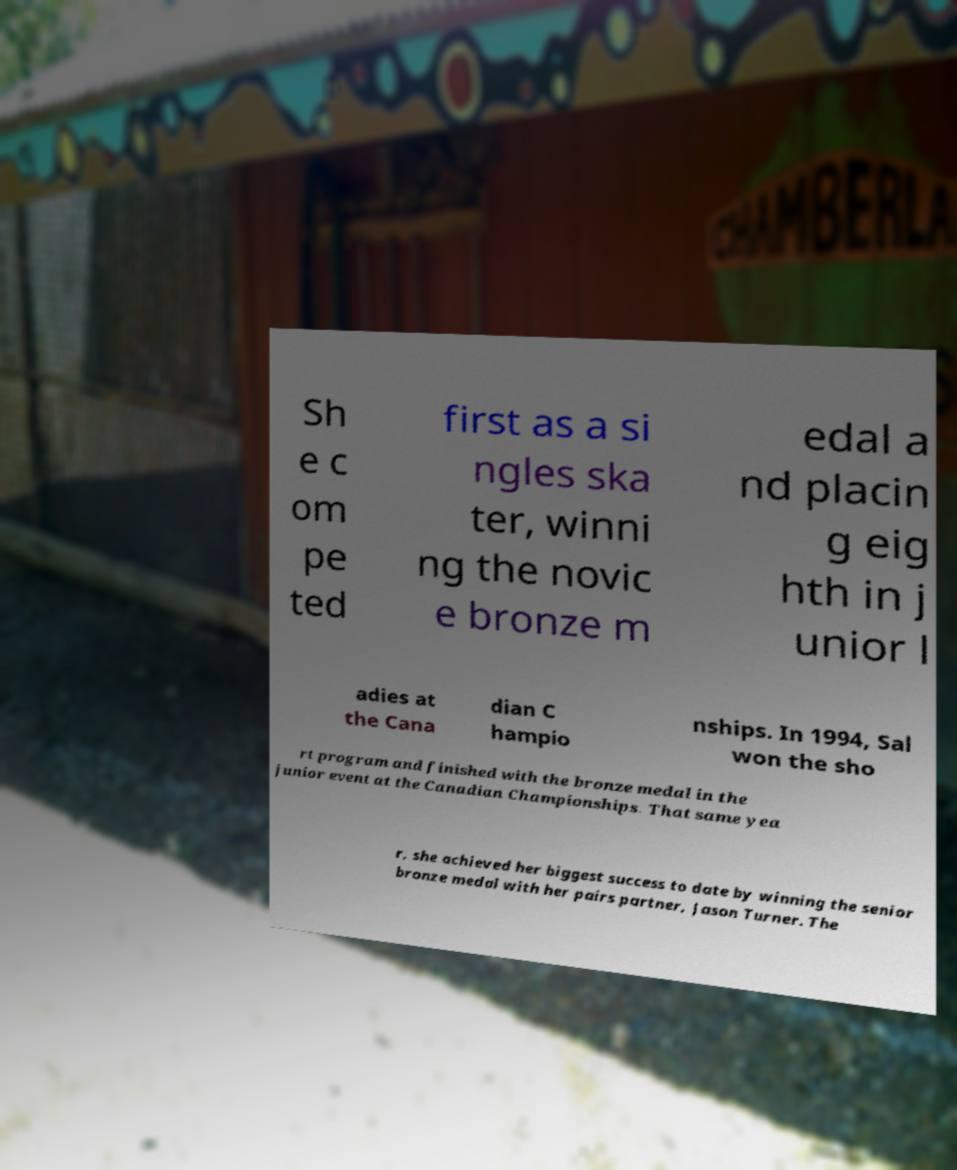Could you assist in decoding the text presented in this image and type it out clearly? Sh e c om pe ted first as a si ngles ska ter, winni ng the novic e bronze m edal a nd placin g eig hth in j unior l adies at the Cana dian C hampio nships. In 1994, Sal won the sho rt program and finished with the bronze medal in the junior event at the Canadian Championships. That same yea r, she achieved her biggest success to date by winning the senior bronze medal with her pairs partner, Jason Turner. The 